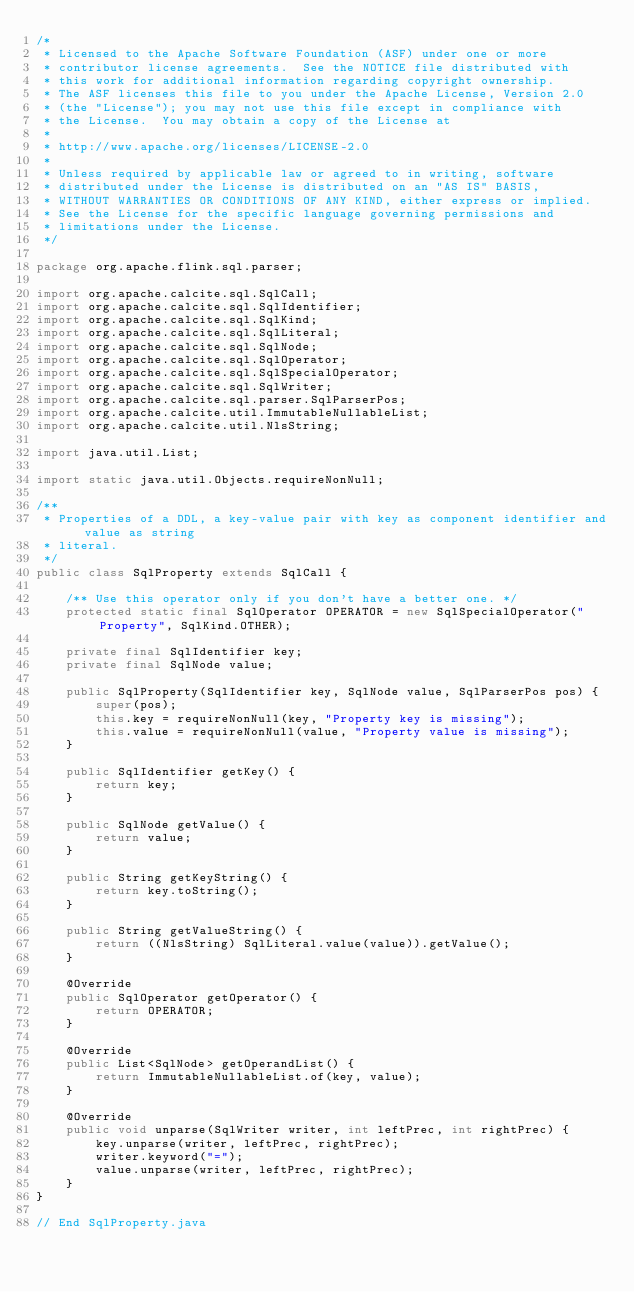Convert code to text. <code><loc_0><loc_0><loc_500><loc_500><_Java_>/*
 * Licensed to the Apache Software Foundation (ASF) under one or more
 * contributor license agreements.  See the NOTICE file distributed with
 * this work for additional information regarding copyright ownership.
 * The ASF licenses this file to you under the Apache License, Version 2.0
 * (the "License"); you may not use this file except in compliance with
 * the License.  You may obtain a copy of the License at
 *
 * http://www.apache.org/licenses/LICENSE-2.0
 *
 * Unless required by applicable law or agreed to in writing, software
 * distributed under the License is distributed on an "AS IS" BASIS,
 * WITHOUT WARRANTIES OR CONDITIONS OF ANY KIND, either express or implied.
 * See the License for the specific language governing permissions and
 * limitations under the License.
 */

package org.apache.flink.sql.parser;

import org.apache.calcite.sql.SqlCall;
import org.apache.calcite.sql.SqlIdentifier;
import org.apache.calcite.sql.SqlKind;
import org.apache.calcite.sql.SqlLiteral;
import org.apache.calcite.sql.SqlNode;
import org.apache.calcite.sql.SqlOperator;
import org.apache.calcite.sql.SqlSpecialOperator;
import org.apache.calcite.sql.SqlWriter;
import org.apache.calcite.sql.parser.SqlParserPos;
import org.apache.calcite.util.ImmutableNullableList;
import org.apache.calcite.util.NlsString;

import java.util.List;

import static java.util.Objects.requireNonNull;

/**
 * Properties of a DDL, a key-value pair with key as component identifier and value as string
 * literal.
 */
public class SqlProperty extends SqlCall {

    /** Use this operator only if you don't have a better one. */
    protected static final SqlOperator OPERATOR = new SqlSpecialOperator("Property", SqlKind.OTHER);

    private final SqlIdentifier key;
    private final SqlNode value;

    public SqlProperty(SqlIdentifier key, SqlNode value, SqlParserPos pos) {
        super(pos);
        this.key = requireNonNull(key, "Property key is missing");
        this.value = requireNonNull(value, "Property value is missing");
    }

    public SqlIdentifier getKey() {
        return key;
    }

    public SqlNode getValue() {
        return value;
    }

    public String getKeyString() {
        return key.toString();
    }

    public String getValueString() {
        return ((NlsString) SqlLiteral.value(value)).getValue();
    }

    @Override
    public SqlOperator getOperator() {
        return OPERATOR;
    }

    @Override
    public List<SqlNode> getOperandList() {
        return ImmutableNullableList.of(key, value);
    }

    @Override
    public void unparse(SqlWriter writer, int leftPrec, int rightPrec) {
        key.unparse(writer, leftPrec, rightPrec);
        writer.keyword("=");
        value.unparse(writer, leftPrec, rightPrec);
    }
}

// End SqlProperty.java
</code> 